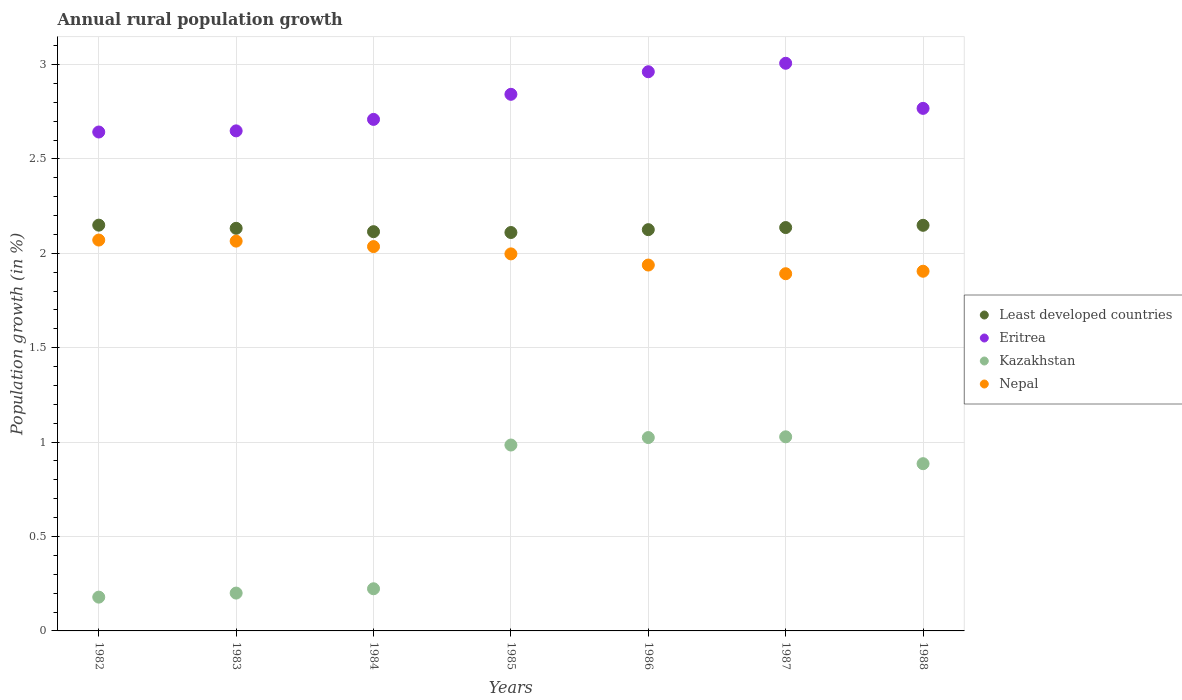How many different coloured dotlines are there?
Your answer should be compact. 4. What is the percentage of rural population growth in Kazakhstan in 1984?
Ensure brevity in your answer.  0.22. Across all years, what is the maximum percentage of rural population growth in Nepal?
Ensure brevity in your answer.  2.07. Across all years, what is the minimum percentage of rural population growth in Eritrea?
Your response must be concise. 2.64. What is the total percentage of rural population growth in Nepal in the graph?
Keep it short and to the point. 13.9. What is the difference between the percentage of rural population growth in Kazakhstan in 1984 and that in 1988?
Your answer should be very brief. -0.66. What is the difference between the percentage of rural population growth in Nepal in 1983 and the percentage of rural population growth in Kazakhstan in 1987?
Give a very brief answer. 1.04. What is the average percentage of rural population growth in Least developed countries per year?
Provide a short and direct response. 2.13. In the year 1983, what is the difference between the percentage of rural population growth in Kazakhstan and percentage of rural population growth in Least developed countries?
Your answer should be compact. -1.93. In how many years, is the percentage of rural population growth in Nepal greater than 0.6 %?
Your answer should be compact. 7. What is the ratio of the percentage of rural population growth in Least developed countries in 1982 to that in 1987?
Your answer should be compact. 1.01. What is the difference between the highest and the second highest percentage of rural population growth in Eritrea?
Keep it short and to the point. 0.04. What is the difference between the highest and the lowest percentage of rural population growth in Least developed countries?
Offer a very short reply. 0.04. Is it the case that in every year, the sum of the percentage of rural population growth in Least developed countries and percentage of rural population growth in Kazakhstan  is greater than the sum of percentage of rural population growth in Nepal and percentage of rural population growth in Eritrea?
Keep it short and to the point. No. Is it the case that in every year, the sum of the percentage of rural population growth in Nepal and percentage of rural population growth in Kazakhstan  is greater than the percentage of rural population growth in Eritrea?
Your answer should be compact. No. Is the percentage of rural population growth in Kazakhstan strictly less than the percentage of rural population growth in Least developed countries over the years?
Provide a succinct answer. Yes. How many dotlines are there?
Provide a short and direct response. 4. How many years are there in the graph?
Keep it short and to the point. 7. Are the values on the major ticks of Y-axis written in scientific E-notation?
Make the answer very short. No. Does the graph contain any zero values?
Your answer should be very brief. No. Does the graph contain grids?
Provide a succinct answer. Yes. What is the title of the graph?
Provide a succinct answer. Annual rural population growth. What is the label or title of the X-axis?
Your answer should be very brief. Years. What is the label or title of the Y-axis?
Make the answer very short. Population growth (in %). What is the Population growth (in %) in Least developed countries in 1982?
Your answer should be compact. 2.15. What is the Population growth (in %) of Eritrea in 1982?
Provide a short and direct response. 2.64. What is the Population growth (in %) of Kazakhstan in 1982?
Provide a succinct answer. 0.18. What is the Population growth (in %) in Nepal in 1982?
Offer a terse response. 2.07. What is the Population growth (in %) in Least developed countries in 1983?
Make the answer very short. 2.13. What is the Population growth (in %) of Eritrea in 1983?
Your answer should be very brief. 2.65. What is the Population growth (in %) in Kazakhstan in 1983?
Offer a terse response. 0.2. What is the Population growth (in %) in Nepal in 1983?
Provide a succinct answer. 2.06. What is the Population growth (in %) in Least developed countries in 1984?
Your answer should be very brief. 2.11. What is the Population growth (in %) in Eritrea in 1984?
Your answer should be very brief. 2.71. What is the Population growth (in %) of Kazakhstan in 1984?
Offer a very short reply. 0.22. What is the Population growth (in %) of Nepal in 1984?
Make the answer very short. 2.04. What is the Population growth (in %) in Least developed countries in 1985?
Your answer should be very brief. 2.11. What is the Population growth (in %) of Eritrea in 1985?
Give a very brief answer. 2.84. What is the Population growth (in %) in Kazakhstan in 1985?
Your answer should be very brief. 0.98. What is the Population growth (in %) in Nepal in 1985?
Your answer should be very brief. 2. What is the Population growth (in %) of Least developed countries in 1986?
Your response must be concise. 2.13. What is the Population growth (in %) in Eritrea in 1986?
Offer a terse response. 2.96. What is the Population growth (in %) of Kazakhstan in 1986?
Offer a very short reply. 1.02. What is the Population growth (in %) of Nepal in 1986?
Offer a terse response. 1.94. What is the Population growth (in %) of Least developed countries in 1987?
Your response must be concise. 2.14. What is the Population growth (in %) in Eritrea in 1987?
Offer a very short reply. 3.01. What is the Population growth (in %) in Kazakhstan in 1987?
Provide a short and direct response. 1.03. What is the Population growth (in %) in Nepal in 1987?
Make the answer very short. 1.89. What is the Population growth (in %) in Least developed countries in 1988?
Offer a very short reply. 2.15. What is the Population growth (in %) in Eritrea in 1988?
Give a very brief answer. 2.77. What is the Population growth (in %) of Kazakhstan in 1988?
Ensure brevity in your answer.  0.89. What is the Population growth (in %) in Nepal in 1988?
Ensure brevity in your answer.  1.91. Across all years, what is the maximum Population growth (in %) of Least developed countries?
Keep it short and to the point. 2.15. Across all years, what is the maximum Population growth (in %) of Eritrea?
Keep it short and to the point. 3.01. Across all years, what is the maximum Population growth (in %) in Kazakhstan?
Keep it short and to the point. 1.03. Across all years, what is the maximum Population growth (in %) in Nepal?
Offer a very short reply. 2.07. Across all years, what is the minimum Population growth (in %) of Least developed countries?
Your answer should be compact. 2.11. Across all years, what is the minimum Population growth (in %) in Eritrea?
Ensure brevity in your answer.  2.64. Across all years, what is the minimum Population growth (in %) of Kazakhstan?
Provide a short and direct response. 0.18. Across all years, what is the minimum Population growth (in %) in Nepal?
Your answer should be very brief. 1.89. What is the total Population growth (in %) of Least developed countries in the graph?
Keep it short and to the point. 14.92. What is the total Population growth (in %) in Eritrea in the graph?
Make the answer very short. 19.58. What is the total Population growth (in %) of Kazakhstan in the graph?
Offer a terse response. 4.53. What is the total Population growth (in %) in Nepal in the graph?
Keep it short and to the point. 13.9. What is the difference between the Population growth (in %) of Least developed countries in 1982 and that in 1983?
Make the answer very short. 0.02. What is the difference between the Population growth (in %) of Eritrea in 1982 and that in 1983?
Your response must be concise. -0.01. What is the difference between the Population growth (in %) of Kazakhstan in 1982 and that in 1983?
Offer a very short reply. -0.02. What is the difference between the Population growth (in %) of Nepal in 1982 and that in 1983?
Make the answer very short. 0.01. What is the difference between the Population growth (in %) in Least developed countries in 1982 and that in 1984?
Ensure brevity in your answer.  0.03. What is the difference between the Population growth (in %) in Eritrea in 1982 and that in 1984?
Offer a very short reply. -0.07. What is the difference between the Population growth (in %) of Kazakhstan in 1982 and that in 1984?
Provide a succinct answer. -0.04. What is the difference between the Population growth (in %) of Nepal in 1982 and that in 1984?
Keep it short and to the point. 0.03. What is the difference between the Population growth (in %) in Least developed countries in 1982 and that in 1985?
Make the answer very short. 0.04. What is the difference between the Population growth (in %) of Eritrea in 1982 and that in 1985?
Your response must be concise. -0.2. What is the difference between the Population growth (in %) in Kazakhstan in 1982 and that in 1985?
Keep it short and to the point. -0.81. What is the difference between the Population growth (in %) of Nepal in 1982 and that in 1985?
Your answer should be compact. 0.07. What is the difference between the Population growth (in %) in Least developed countries in 1982 and that in 1986?
Your answer should be very brief. 0.02. What is the difference between the Population growth (in %) of Eritrea in 1982 and that in 1986?
Keep it short and to the point. -0.32. What is the difference between the Population growth (in %) of Kazakhstan in 1982 and that in 1986?
Offer a terse response. -0.85. What is the difference between the Population growth (in %) of Nepal in 1982 and that in 1986?
Offer a very short reply. 0.13. What is the difference between the Population growth (in %) in Least developed countries in 1982 and that in 1987?
Make the answer very short. 0.01. What is the difference between the Population growth (in %) of Eritrea in 1982 and that in 1987?
Offer a very short reply. -0.36. What is the difference between the Population growth (in %) of Kazakhstan in 1982 and that in 1987?
Offer a very short reply. -0.85. What is the difference between the Population growth (in %) of Nepal in 1982 and that in 1987?
Offer a terse response. 0.18. What is the difference between the Population growth (in %) in Least developed countries in 1982 and that in 1988?
Keep it short and to the point. 0. What is the difference between the Population growth (in %) of Eritrea in 1982 and that in 1988?
Provide a short and direct response. -0.13. What is the difference between the Population growth (in %) in Kazakhstan in 1982 and that in 1988?
Offer a terse response. -0.71. What is the difference between the Population growth (in %) in Nepal in 1982 and that in 1988?
Provide a succinct answer. 0.17. What is the difference between the Population growth (in %) in Least developed countries in 1983 and that in 1984?
Offer a very short reply. 0.02. What is the difference between the Population growth (in %) in Eritrea in 1983 and that in 1984?
Your answer should be compact. -0.06. What is the difference between the Population growth (in %) of Kazakhstan in 1983 and that in 1984?
Make the answer very short. -0.02. What is the difference between the Population growth (in %) in Nepal in 1983 and that in 1984?
Give a very brief answer. 0.03. What is the difference between the Population growth (in %) in Least developed countries in 1983 and that in 1985?
Your answer should be very brief. 0.02. What is the difference between the Population growth (in %) in Eritrea in 1983 and that in 1985?
Ensure brevity in your answer.  -0.19. What is the difference between the Population growth (in %) of Kazakhstan in 1983 and that in 1985?
Provide a short and direct response. -0.78. What is the difference between the Population growth (in %) in Nepal in 1983 and that in 1985?
Provide a short and direct response. 0.07. What is the difference between the Population growth (in %) of Least developed countries in 1983 and that in 1986?
Make the answer very short. 0.01. What is the difference between the Population growth (in %) of Eritrea in 1983 and that in 1986?
Your answer should be compact. -0.31. What is the difference between the Population growth (in %) in Kazakhstan in 1983 and that in 1986?
Your response must be concise. -0.82. What is the difference between the Population growth (in %) of Nepal in 1983 and that in 1986?
Keep it short and to the point. 0.13. What is the difference between the Population growth (in %) of Least developed countries in 1983 and that in 1987?
Offer a very short reply. -0. What is the difference between the Population growth (in %) of Eritrea in 1983 and that in 1987?
Give a very brief answer. -0.36. What is the difference between the Population growth (in %) of Kazakhstan in 1983 and that in 1987?
Your response must be concise. -0.83. What is the difference between the Population growth (in %) in Nepal in 1983 and that in 1987?
Offer a terse response. 0.17. What is the difference between the Population growth (in %) in Least developed countries in 1983 and that in 1988?
Make the answer very short. -0.02. What is the difference between the Population growth (in %) of Eritrea in 1983 and that in 1988?
Provide a succinct answer. -0.12. What is the difference between the Population growth (in %) of Kazakhstan in 1983 and that in 1988?
Offer a very short reply. -0.69. What is the difference between the Population growth (in %) of Nepal in 1983 and that in 1988?
Provide a short and direct response. 0.16. What is the difference between the Population growth (in %) in Least developed countries in 1984 and that in 1985?
Your answer should be compact. 0. What is the difference between the Population growth (in %) in Eritrea in 1984 and that in 1985?
Keep it short and to the point. -0.13. What is the difference between the Population growth (in %) of Kazakhstan in 1984 and that in 1985?
Keep it short and to the point. -0.76. What is the difference between the Population growth (in %) of Nepal in 1984 and that in 1985?
Provide a short and direct response. 0.04. What is the difference between the Population growth (in %) of Least developed countries in 1984 and that in 1986?
Your answer should be very brief. -0.01. What is the difference between the Population growth (in %) in Eritrea in 1984 and that in 1986?
Provide a short and direct response. -0.25. What is the difference between the Population growth (in %) of Kazakhstan in 1984 and that in 1986?
Provide a succinct answer. -0.8. What is the difference between the Population growth (in %) in Nepal in 1984 and that in 1986?
Offer a very short reply. 0.1. What is the difference between the Population growth (in %) of Least developed countries in 1984 and that in 1987?
Your answer should be compact. -0.02. What is the difference between the Population growth (in %) of Eritrea in 1984 and that in 1987?
Keep it short and to the point. -0.3. What is the difference between the Population growth (in %) in Kazakhstan in 1984 and that in 1987?
Your answer should be very brief. -0.8. What is the difference between the Population growth (in %) in Nepal in 1984 and that in 1987?
Make the answer very short. 0.14. What is the difference between the Population growth (in %) of Least developed countries in 1984 and that in 1988?
Ensure brevity in your answer.  -0.03. What is the difference between the Population growth (in %) in Eritrea in 1984 and that in 1988?
Offer a terse response. -0.06. What is the difference between the Population growth (in %) of Kazakhstan in 1984 and that in 1988?
Offer a very short reply. -0.66. What is the difference between the Population growth (in %) of Nepal in 1984 and that in 1988?
Provide a short and direct response. 0.13. What is the difference between the Population growth (in %) in Least developed countries in 1985 and that in 1986?
Your answer should be very brief. -0.02. What is the difference between the Population growth (in %) of Eritrea in 1985 and that in 1986?
Provide a succinct answer. -0.12. What is the difference between the Population growth (in %) in Kazakhstan in 1985 and that in 1986?
Ensure brevity in your answer.  -0.04. What is the difference between the Population growth (in %) of Nepal in 1985 and that in 1986?
Provide a succinct answer. 0.06. What is the difference between the Population growth (in %) in Least developed countries in 1985 and that in 1987?
Your answer should be compact. -0.03. What is the difference between the Population growth (in %) of Eritrea in 1985 and that in 1987?
Give a very brief answer. -0.16. What is the difference between the Population growth (in %) of Kazakhstan in 1985 and that in 1987?
Your response must be concise. -0.04. What is the difference between the Population growth (in %) in Nepal in 1985 and that in 1987?
Your response must be concise. 0.11. What is the difference between the Population growth (in %) in Least developed countries in 1985 and that in 1988?
Give a very brief answer. -0.04. What is the difference between the Population growth (in %) in Eritrea in 1985 and that in 1988?
Your answer should be very brief. 0.07. What is the difference between the Population growth (in %) of Kazakhstan in 1985 and that in 1988?
Ensure brevity in your answer.  0.1. What is the difference between the Population growth (in %) of Nepal in 1985 and that in 1988?
Offer a terse response. 0.09. What is the difference between the Population growth (in %) of Least developed countries in 1986 and that in 1987?
Give a very brief answer. -0.01. What is the difference between the Population growth (in %) of Eritrea in 1986 and that in 1987?
Your response must be concise. -0.04. What is the difference between the Population growth (in %) of Kazakhstan in 1986 and that in 1987?
Your response must be concise. -0. What is the difference between the Population growth (in %) of Nepal in 1986 and that in 1987?
Provide a short and direct response. 0.05. What is the difference between the Population growth (in %) in Least developed countries in 1986 and that in 1988?
Your response must be concise. -0.02. What is the difference between the Population growth (in %) in Eritrea in 1986 and that in 1988?
Keep it short and to the point. 0.19. What is the difference between the Population growth (in %) of Kazakhstan in 1986 and that in 1988?
Provide a succinct answer. 0.14. What is the difference between the Population growth (in %) in Nepal in 1986 and that in 1988?
Your response must be concise. 0.03. What is the difference between the Population growth (in %) of Least developed countries in 1987 and that in 1988?
Ensure brevity in your answer.  -0.01. What is the difference between the Population growth (in %) of Eritrea in 1987 and that in 1988?
Keep it short and to the point. 0.24. What is the difference between the Population growth (in %) in Kazakhstan in 1987 and that in 1988?
Provide a short and direct response. 0.14. What is the difference between the Population growth (in %) of Nepal in 1987 and that in 1988?
Your response must be concise. -0.01. What is the difference between the Population growth (in %) in Least developed countries in 1982 and the Population growth (in %) in Eritrea in 1983?
Ensure brevity in your answer.  -0.5. What is the difference between the Population growth (in %) in Least developed countries in 1982 and the Population growth (in %) in Kazakhstan in 1983?
Make the answer very short. 1.95. What is the difference between the Population growth (in %) in Least developed countries in 1982 and the Population growth (in %) in Nepal in 1983?
Provide a short and direct response. 0.08. What is the difference between the Population growth (in %) in Eritrea in 1982 and the Population growth (in %) in Kazakhstan in 1983?
Offer a very short reply. 2.44. What is the difference between the Population growth (in %) of Eritrea in 1982 and the Population growth (in %) of Nepal in 1983?
Your answer should be compact. 0.58. What is the difference between the Population growth (in %) of Kazakhstan in 1982 and the Population growth (in %) of Nepal in 1983?
Provide a succinct answer. -1.89. What is the difference between the Population growth (in %) of Least developed countries in 1982 and the Population growth (in %) of Eritrea in 1984?
Your answer should be very brief. -0.56. What is the difference between the Population growth (in %) of Least developed countries in 1982 and the Population growth (in %) of Kazakhstan in 1984?
Offer a terse response. 1.93. What is the difference between the Population growth (in %) in Least developed countries in 1982 and the Population growth (in %) in Nepal in 1984?
Your answer should be very brief. 0.11. What is the difference between the Population growth (in %) of Eritrea in 1982 and the Population growth (in %) of Kazakhstan in 1984?
Your response must be concise. 2.42. What is the difference between the Population growth (in %) in Eritrea in 1982 and the Population growth (in %) in Nepal in 1984?
Make the answer very short. 0.61. What is the difference between the Population growth (in %) of Kazakhstan in 1982 and the Population growth (in %) of Nepal in 1984?
Give a very brief answer. -1.86. What is the difference between the Population growth (in %) in Least developed countries in 1982 and the Population growth (in %) in Eritrea in 1985?
Your answer should be compact. -0.69. What is the difference between the Population growth (in %) of Least developed countries in 1982 and the Population growth (in %) of Kazakhstan in 1985?
Your answer should be very brief. 1.16. What is the difference between the Population growth (in %) in Least developed countries in 1982 and the Population growth (in %) in Nepal in 1985?
Keep it short and to the point. 0.15. What is the difference between the Population growth (in %) in Eritrea in 1982 and the Population growth (in %) in Kazakhstan in 1985?
Offer a very short reply. 1.66. What is the difference between the Population growth (in %) of Eritrea in 1982 and the Population growth (in %) of Nepal in 1985?
Your answer should be very brief. 0.65. What is the difference between the Population growth (in %) of Kazakhstan in 1982 and the Population growth (in %) of Nepal in 1985?
Ensure brevity in your answer.  -1.82. What is the difference between the Population growth (in %) of Least developed countries in 1982 and the Population growth (in %) of Eritrea in 1986?
Keep it short and to the point. -0.81. What is the difference between the Population growth (in %) in Least developed countries in 1982 and the Population growth (in %) in Nepal in 1986?
Your answer should be compact. 0.21. What is the difference between the Population growth (in %) in Eritrea in 1982 and the Population growth (in %) in Kazakhstan in 1986?
Your answer should be very brief. 1.62. What is the difference between the Population growth (in %) of Eritrea in 1982 and the Population growth (in %) of Nepal in 1986?
Your answer should be compact. 0.7. What is the difference between the Population growth (in %) of Kazakhstan in 1982 and the Population growth (in %) of Nepal in 1986?
Your response must be concise. -1.76. What is the difference between the Population growth (in %) of Least developed countries in 1982 and the Population growth (in %) of Eritrea in 1987?
Offer a terse response. -0.86. What is the difference between the Population growth (in %) in Least developed countries in 1982 and the Population growth (in %) in Kazakhstan in 1987?
Your answer should be compact. 1.12. What is the difference between the Population growth (in %) of Least developed countries in 1982 and the Population growth (in %) of Nepal in 1987?
Your answer should be very brief. 0.26. What is the difference between the Population growth (in %) in Eritrea in 1982 and the Population growth (in %) in Kazakhstan in 1987?
Your answer should be compact. 1.61. What is the difference between the Population growth (in %) in Eritrea in 1982 and the Population growth (in %) in Nepal in 1987?
Make the answer very short. 0.75. What is the difference between the Population growth (in %) in Kazakhstan in 1982 and the Population growth (in %) in Nepal in 1987?
Offer a very short reply. -1.71. What is the difference between the Population growth (in %) of Least developed countries in 1982 and the Population growth (in %) of Eritrea in 1988?
Provide a short and direct response. -0.62. What is the difference between the Population growth (in %) of Least developed countries in 1982 and the Population growth (in %) of Kazakhstan in 1988?
Your answer should be very brief. 1.26. What is the difference between the Population growth (in %) in Least developed countries in 1982 and the Population growth (in %) in Nepal in 1988?
Offer a very short reply. 0.24. What is the difference between the Population growth (in %) of Eritrea in 1982 and the Population growth (in %) of Kazakhstan in 1988?
Offer a very short reply. 1.76. What is the difference between the Population growth (in %) in Eritrea in 1982 and the Population growth (in %) in Nepal in 1988?
Provide a short and direct response. 0.74. What is the difference between the Population growth (in %) in Kazakhstan in 1982 and the Population growth (in %) in Nepal in 1988?
Give a very brief answer. -1.73. What is the difference between the Population growth (in %) in Least developed countries in 1983 and the Population growth (in %) in Eritrea in 1984?
Ensure brevity in your answer.  -0.58. What is the difference between the Population growth (in %) in Least developed countries in 1983 and the Population growth (in %) in Kazakhstan in 1984?
Your answer should be compact. 1.91. What is the difference between the Population growth (in %) of Least developed countries in 1983 and the Population growth (in %) of Nepal in 1984?
Your answer should be compact. 0.1. What is the difference between the Population growth (in %) in Eritrea in 1983 and the Population growth (in %) in Kazakhstan in 1984?
Provide a short and direct response. 2.43. What is the difference between the Population growth (in %) of Eritrea in 1983 and the Population growth (in %) of Nepal in 1984?
Offer a very short reply. 0.61. What is the difference between the Population growth (in %) of Kazakhstan in 1983 and the Population growth (in %) of Nepal in 1984?
Your answer should be very brief. -1.84. What is the difference between the Population growth (in %) of Least developed countries in 1983 and the Population growth (in %) of Eritrea in 1985?
Your answer should be compact. -0.71. What is the difference between the Population growth (in %) in Least developed countries in 1983 and the Population growth (in %) in Kazakhstan in 1985?
Give a very brief answer. 1.15. What is the difference between the Population growth (in %) of Least developed countries in 1983 and the Population growth (in %) of Nepal in 1985?
Provide a succinct answer. 0.14. What is the difference between the Population growth (in %) in Eritrea in 1983 and the Population growth (in %) in Kazakhstan in 1985?
Make the answer very short. 1.66. What is the difference between the Population growth (in %) in Eritrea in 1983 and the Population growth (in %) in Nepal in 1985?
Make the answer very short. 0.65. What is the difference between the Population growth (in %) of Kazakhstan in 1983 and the Population growth (in %) of Nepal in 1985?
Offer a very short reply. -1.8. What is the difference between the Population growth (in %) in Least developed countries in 1983 and the Population growth (in %) in Eritrea in 1986?
Make the answer very short. -0.83. What is the difference between the Population growth (in %) of Least developed countries in 1983 and the Population growth (in %) of Kazakhstan in 1986?
Provide a short and direct response. 1.11. What is the difference between the Population growth (in %) of Least developed countries in 1983 and the Population growth (in %) of Nepal in 1986?
Offer a terse response. 0.19. What is the difference between the Population growth (in %) of Eritrea in 1983 and the Population growth (in %) of Kazakhstan in 1986?
Offer a terse response. 1.62. What is the difference between the Population growth (in %) of Eritrea in 1983 and the Population growth (in %) of Nepal in 1986?
Give a very brief answer. 0.71. What is the difference between the Population growth (in %) in Kazakhstan in 1983 and the Population growth (in %) in Nepal in 1986?
Your answer should be compact. -1.74. What is the difference between the Population growth (in %) of Least developed countries in 1983 and the Population growth (in %) of Eritrea in 1987?
Provide a short and direct response. -0.87. What is the difference between the Population growth (in %) in Least developed countries in 1983 and the Population growth (in %) in Kazakhstan in 1987?
Your response must be concise. 1.1. What is the difference between the Population growth (in %) of Least developed countries in 1983 and the Population growth (in %) of Nepal in 1987?
Your answer should be very brief. 0.24. What is the difference between the Population growth (in %) of Eritrea in 1983 and the Population growth (in %) of Kazakhstan in 1987?
Provide a succinct answer. 1.62. What is the difference between the Population growth (in %) of Eritrea in 1983 and the Population growth (in %) of Nepal in 1987?
Keep it short and to the point. 0.76. What is the difference between the Population growth (in %) of Kazakhstan in 1983 and the Population growth (in %) of Nepal in 1987?
Your answer should be very brief. -1.69. What is the difference between the Population growth (in %) of Least developed countries in 1983 and the Population growth (in %) of Eritrea in 1988?
Your response must be concise. -0.64. What is the difference between the Population growth (in %) of Least developed countries in 1983 and the Population growth (in %) of Kazakhstan in 1988?
Offer a very short reply. 1.25. What is the difference between the Population growth (in %) of Least developed countries in 1983 and the Population growth (in %) of Nepal in 1988?
Keep it short and to the point. 0.23. What is the difference between the Population growth (in %) in Eritrea in 1983 and the Population growth (in %) in Kazakhstan in 1988?
Your answer should be very brief. 1.76. What is the difference between the Population growth (in %) in Eritrea in 1983 and the Population growth (in %) in Nepal in 1988?
Your response must be concise. 0.74. What is the difference between the Population growth (in %) in Kazakhstan in 1983 and the Population growth (in %) in Nepal in 1988?
Provide a short and direct response. -1.7. What is the difference between the Population growth (in %) of Least developed countries in 1984 and the Population growth (in %) of Eritrea in 1985?
Provide a succinct answer. -0.73. What is the difference between the Population growth (in %) in Least developed countries in 1984 and the Population growth (in %) in Kazakhstan in 1985?
Your answer should be compact. 1.13. What is the difference between the Population growth (in %) in Least developed countries in 1984 and the Population growth (in %) in Nepal in 1985?
Ensure brevity in your answer.  0.12. What is the difference between the Population growth (in %) in Eritrea in 1984 and the Population growth (in %) in Kazakhstan in 1985?
Make the answer very short. 1.72. What is the difference between the Population growth (in %) in Eritrea in 1984 and the Population growth (in %) in Nepal in 1985?
Keep it short and to the point. 0.71. What is the difference between the Population growth (in %) of Kazakhstan in 1984 and the Population growth (in %) of Nepal in 1985?
Your response must be concise. -1.77. What is the difference between the Population growth (in %) of Least developed countries in 1984 and the Population growth (in %) of Eritrea in 1986?
Make the answer very short. -0.85. What is the difference between the Population growth (in %) of Least developed countries in 1984 and the Population growth (in %) of Kazakhstan in 1986?
Provide a short and direct response. 1.09. What is the difference between the Population growth (in %) of Least developed countries in 1984 and the Population growth (in %) of Nepal in 1986?
Provide a succinct answer. 0.18. What is the difference between the Population growth (in %) in Eritrea in 1984 and the Population growth (in %) in Kazakhstan in 1986?
Keep it short and to the point. 1.69. What is the difference between the Population growth (in %) of Eritrea in 1984 and the Population growth (in %) of Nepal in 1986?
Your response must be concise. 0.77. What is the difference between the Population growth (in %) of Kazakhstan in 1984 and the Population growth (in %) of Nepal in 1986?
Offer a terse response. -1.71. What is the difference between the Population growth (in %) of Least developed countries in 1984 and the Population growth (in %) of Eritrea in 1987?
Provide a short and direct response. -0.89. What is the difference between the Population growth (in %) of Least developed countries in 1984 and the Population growth (in %) of Kazakhstan in 1987?
Your answer should be compact. 1.09. What is the difference between the Population growth (in %) of Least developed countries in 1984 and the Population growth (in %) of Nepal in 1987?
Offer a terse response. 0.22. What is the difference between the Population growth (in %) in Eritrea in 1984 and the Population growth (in %) in Kazakhstan in 1987?
Make the answer very short. 1.68. What is the difference between the Population growth (in %) in Eritrea in 1984 and the Population growth (in %) in Nepal in 1987?
Your answer should be compact. 0.82. What is the difference between the Population growth (in %) in Kazakhstan in 1984 and the Population growth (in %) in Nepal in 1987?
Your answer should be very brief. -1.67. What is the difference between the Population growth (in %) in Least developed countries in 1984 and the Population growth (in %) in Eritrea in 1988?
Provide a succinct answer. -0.65. What is the difference between the Population growth (in %) in Least developed countries in 1984 and the Population growth (in %) in Kazakhstan in 1988?
Ensure brevity in your answer.  1.23. What is the difference between the Population growth (in %) in Least developed countries in 1984 and the Population growth (in %) in Nepal in 1988?
Provide a succinct answer. 0.21. What is the difference between the Population growth (in %) of Eritrea in 1984 and the Population growth (in %) of Kazakhstan in 1988?
Your answer should be compact. 1.82. What is the difference between the Population growth (in %) in Eritrea in 1984 and the Population growth (in %) in Nepal in 1988?
Offer a very short reply. 0.8. What is the difference between the Population growth (in %) of Kazakhstan in 1984 and the Population growth (in %) of Nepal in 1988?
Offer a terse response. -1.68. What is the difference between the Population growth (in %) in Least developed countries in 1985 and the Population growth (in %) in Eritrea in 1986?
Offer a very short reply. -0.85. What is the difference between the Population growth (in %) in Least developed countries in 1985 and the Population growth (in %) in Kazakhstan in 1986?
Give a very brief answer. 1.09. What is the difference between the Population growth (in %) of Least developed countries in 1985 and the Population growth (in %) of Nepal in 1986?
Offer a very short reply. 0.17. What is the difference between the Population growth (in %) of Eritrea in 1985 and the Population growth (in %) of Kazakhstan in 1986?
Your answer should be very brief. 1.82. What is the difference between the Population growth (in %) of Eritrea in 1985 and the Population growth (in %) of Nepal in 1986?
Your response must be concise. 0.9. What is the difference between the Population growth (in %) of Kazakhstan in 1985 and the Population growth (in %) of Nepal in 1986?
Ensure brevity in your answer.  -0.95. What is the difference between the Population growth (in %) in Least developed countries in 1985 and the Population growth (in %) in Eritrea in 1987?
Offer a very short reply. -0.9. What is the difference between the Population growth (in %) of Least developed countries in 1985 and the Population growth (in %) of Kazakhstan in 1987?
Offer a very short reply. 1.08. What is the difference between the Population growth (in %) in Least developed countries in 1985 and the Population growth (in %) in Nepal in 1987?
Ensure brevity in your answer.  0.22. What is the difference between the Population growth (in %) of Eritrea in 1985 and the Population growth (in %) of Kazakhstan in 1987?
Ensure brevity in your answer.  1.81. What is the difference between the Population growth (in %) in Eritrea in 1985 and the Population growth (in %) in Nepal in 1987?
Your response must be concise. 0.95. What is the difference between the Population growth (in %) in Kazakhstan in 1985 and the Population growth (in %) in Nepal in 1987?
Provide a succinct answer. -0.91. What is the difference between the Population growth (in %) of Least developed countries in 1985 and the Population growth (in %) of Eritrea in 1988?
Provide a succinct answer. -0.66. What is the difference between the Population growth (in %) in Least developed countries in 1985 and the Population growth (in %) in Kazakhstan in 1988?
Offer a terse response. 1.22. What is the difference between the Population growth (in %) of Least developed countries in 1985 and the Population growth (in %) of Nepal in 1988?
Keep it short and to the point. 0.21. What is the difference between the Population growth (in %) in Eritrea in 1985 and the Population growth (in %) in Kazakhstan in 1988?
Your answer should be very brief. 1.96. What is the difference between the Population growth (in %) of Eritrea in 1985 and the Population growth (in %) of Nepal in 1988?
Your response must be concise. 0.94. What is the difference between the Population growth (in %) of Kazakhstan in 1985 and the Population growth (in %) of Nepal in 1988?
Offer a terse response. -0.92. What is the difference between the Population growth (in %) in Least developed countries in 1986 and the Population growth (in %) in Eritrea in 1987?
Keep it short and to the point. -0.88. What is the difference between the Population growth (in %) of Least developed countries in 1986 and the Population growth (in %) of Kazakhstan in 1987?
Give a very brief answer. 1.1. What is the difference between the Population growth (in %) of Least developed countries in 1986 and the Population growth (in %) of Nepal in 1987?
Provide a short and direct response. 0.23. What is the difference between the Population growth (in %) of Eritrea in 1986 and the Population growth (in %) of Kazakhstan in 1987?
Your answer should be very brief. 1.93. What is the difference between the Population growth (in %) in Eritrea in 1986 and the Population growth (in %) in Nepal in 1987?
Offer a very short reply. 1.07. What is the difference between the Population growth (in %) in Kazakhstan in 1986 and the Population growth (in %) in Nepal in 1987?
Your answer should be very brief. -0.87. What is the difference between the Population growth (in %) in Least developed countries in 1986 and the Population growth (in %) in Eritrea in 1988?
Make the answer very short. -0.64. What is the difference between the Population growth (in %) of Least developed countries in 1986 and the Population growth (in %) of Kazakhstan in 1988?
Provide a succinct answer. 1.24. What is the difference between the Population growth (in %) in Least developed countries in 1986 and the Population growth (in %) in Nepal in 1988?
Offer a terse response. 0.22. What is the difference between the Population growth (in %) of Eritrea in 1986 and the Population growth (in %) of Kazakhstan in 1988?
Ensure brevity in your answer.  2.08. What is the difference between the Population growth (in %) in Eritrea in 1986 and the Population growth (in %) in Nepal in 1988?
Provide a succinct answer. 1.06. What is the difference between the Population growth (in %) in Kazakhstan in 1986 and the Population growth (in %) in Nepal in 1988?
Your response must be concise. -0.88. What is the difference between the Population growth (in %) in Least developed countries in 1987 and the Population growth (in %) in Eritrea in 1988?
Your answer should be compact. -0.63. What is the difference between the Population growth (in %) in Least developed countries in 1987 and the Population growth (in %) in Kazakhstan in 1988?
Provide a short and direct response. 1.25. What is the difference between the Population growth (in %) of Least developed countries in 1987 and the Population growth (in %) of Nepal in 1988?
Provide a succinct answer. 0.23. What is the difference between the Population growth (in %) in Eritrea in 1987 and the Population growth (in %) in Kazakhstan in 1988?
Offer a terse response. 2.12. What is the difference between the Population growth (in %) in Eritrea in 1987 and the Population growth (in %) in Nepal in 1988?
Your answer should be compact. 1.1. What is the difference between the Population growth (in %) in Kazakhstan in 1987 and the Population growth (in %) in Nepal in 1988?
Give a very brief answer. -0.88. What is the average Population growth (in %) in Least developed countries per year?
Offer a very short reply. 2.13. What is the average Population growth (in %) of Eritrea per year?
Keep it short and to the point. 2.8. What is the average Population growth (in %) in Kazakhstan per year?
Offer a terse response. 0.65. What is the average Population growth (in %) in Nepal per year?
Your answer should be very brief. 1.99. In the year 1982, what is the difference between the Population growth (in %) in Least developed countries and Population growth (in %) in Eritrea?
Ensure brevity in your answer.  -0.49. In the year 1982, what is the difference between the Population growth (in %) of Least developed countries and Population growth (in %) of Kazakhstan?
Your answer should be compact. 1.97. In the year 1982, what is the difference between the Population growth (in %) in Least developed countries and Population growth (in %) in Nepal?
Keep it short and to the point. 0.08. In the year 1982, what is the difference between the Population growth (in %) of Eritrea and Population growth (in %) of Kazakhstan?
Ensure brevity in your answer.  2.46. In the year 1982, what is the difference between the Population growth (in %) in Eritrea and Population growth (in %) in Nepal?
Keep it short and to the point. 0.57. In the year 1982, what is the difference between the Population growth (in %) in Kazakhstan and Population growth (in %) in Nepal?
Your response must be concise. -1.89. In the year 1983, what is the difference between the Population growth (in %) in Least developed countries and Population growth (in %) in Eritrea?
Provide a short and direct response. -0.52. In the year 1983, what is the difference between the Population growth (in %) of Least developed countries and Population growth (in %) of Kazakhstan?
Offer a very short reply. 1.93. In the year 1983, what is the difference between the Population growth (in %) of Least developed countries and Population growth (in %) of Nepal?
Your answer should be very brief. 0.07. In the year 1983, what is the difference between the Population growth (in %) in Eritrea and Population growth (in %) in Kazakhstan?
Provide a succinct answer. 2.45. In the year 1983, what is the difference between the Population growth (in %) of Eritrea and Population growth (in %) of Nepal?
Your answer should be very brief. 0.58. In the year 1983, what is the difference between the Population growth (in %) in Kazakhstan and Population growth (in %) in Nepal?
Make the answer very short. -1.86. In the year 1984, what is the difference between the Population growth (in %) of Least developed countries and Population growth (in %) of Eritrea?
Ensure brevity in your answer.  -0.59. In the year 1984, what is the difference between the Population growth (in %) of Least developed countries and Population growth (in %) of Kazakhstan?
Your response must be concise. 1.89. In the year 1984, what is the difference between the Population growth (in %) in Least developed countries and Population growth (in %) in Nepal?
Make the answer very short. 0.08. In the year 1984, what is the difference between the Population growth (in %) in Eritrea and Population growth (in %) in Kazakhstan?
Your answer should be compact. 2.49. In the year 1984, what is the difference between the Population growth (in %) in Eritrea and Population growth (in %) in Nepal?
Make the answer very short. 0.67. In the year 1984, what is the difference between the Population growth (in %) in Kazakhstan and Population growth (in %) in Nepal?
Keep it short and to the point. -1.81. In the year 1985, what is the difference between the Population growth (in %) of Least developed countries and Population growth (in %) of Eritrea?
Provide a short and direct response. -0.73. In the year 1985, what is the difference between the Population growth (in %) in Least developed countries and Population growth (in %) in Kazakhstan?
Your answer should be compact. 1.13. In the year 1985, what is the difference between the Population growth (in %) in Least developed countries and Population growth (in %) in Nepal?
Make the answer very short. 0.11. In the year 1985, what is the difference between the Population growth (in %) of Eritrea and Population growth (in %) of Kazakhstan?
Provide a short and direct response. 1.86. In the year 1985, what is the difference between the Population growth (in %) of Eritrea and Population growth (in %) of Nepal?
Offer a terse response. 0.85. In the year 1985, what is the difference between the Population growth (in %) of Kazakhstan and Population growth (in %) of Nepal?
Keep it short and to the point. -1.01. In the year 1986, what is the difference between the Population growth (in %) of Least developed countries and Population growth (in %) of Eritrea?
Offer a very short reply. -0.84. In the year 1986, what is the difference between the Population growth (in %) in Least developed countries and Population growth (in %) in Kazakhstan?
Give a very brief answer. 1.1. In the year 1986, what is the difference between the Population growth (in %) in Least developed countries and Population growth (in %) in Nepal?
Offer a very short reply. 0.19. In the year 1986, what is the difference between the Population growth (in %) in Eritrea and Population growth (in %) in Kazakhstan?
Provide a short and direct response. 1.94. In the year 1986, what is the difference between the Population growth (in %) in Eritrea and Population growth (in %) in Nepal?
Your answer should be compact. 1.02. In the year 1986, what is the difference between the Population growth (in %) of Kazakhstan and Population growth (in %) of Nepal?
Provide a succinct answer. -0.91. In the year 1987, what is the difference between the Population growth (in %) in Least developed countries and Population growth (in %) in Eritrea?
Your answer should be compact. -0.87. In the year 1987, what is the difference between the Population growth (in %) in Least developed countries and Population growth (in %) in Kazakhstan?
Provide a short and direct response. 1.11. In the year 1987, what is the difference between the Population growth (in %) in Least developed countries and Population growth (in %) in Nepal?
Provide a succinct answer. 0.24. In the year 1987, what is the difference between the Population growth (in %) in Eritrea and Population growth (in %) in Kazakhstan?
Offer a terse response. 1.98. In the year 1987, what is the difference between the Population growth (in %) of Eritrea and Population growth (in %) of Nepal?
Offer a very short reply. 1.11. In the year 1987, what is the difference between the Population growth (in %) in Kazakhstan and Population growth (in %) in Nepal?
Your response must be concise. -0.86. In the year 1988, what is the difference between the Population growth (in %) in Least developed countries and Population growth (in %) in Eritrea?
Provide a short and direct response. -0.62. In the year 1988, what is the difference between the Population growth (in %) in Least developed countries and Population growth (in %) in Kazakhstan?
Your response must be concise. 1.26. In the year 1988, what is the difference between the Population growth (in %) in Least developed countries and Population growth (in %) in Nepal?
Your response must be concise. 0.24. In the year 1988, what is the difference between the Population growth (in %) in Eritrea and Population growth (in %) in Kazakhstan?
Ensure brevity in your answer.  1.88. In the year 1988, what is the difference between the Population growth (in %) of Eritrea and Population growth (in %) of Nepal?
Offer a very short reply. 0.86. In the year 1988, what is the difference between the Population growth (in %) in Kazakhstan and Population growth (in %) in Nepal?
Keep it short and to the point. -1.02. What is the ratio of the Population growth (in %) of Least developed countries in 1982 to that in 1983?
Your answer should be very brief. 1.01. What is the ratio of the Population growth (in %) of Eritrea in 1982 to that in 1983?
Provide a short and direct response. 1. What is the ratio of the Population growth (in %) in Kazakhstan in 1982 to that in 1983?
Your answer should be compact. 0.89. What is the ratio of the Population growth (in %) of Least developed countries in 1982 to that in 1984?
Offer a very short reply. 1.02. What is the ratio of the Population growth (in %) in Eritrea in 1982 to that in 1984?
Provide a short and direct response. 0.98. What is the ratio of the Population growth (in %) of Kazakhstan in 1982 to that in 1984?
Your answer should be compact. 0.8. What is the ratio of the Population growth (in %) of Nepal in 1982 to that in 1984?
Your response must be concise. 1.02. What is the ratio of the Population growth (in %) in Least developed countries in 1982 to that in 1985?
Your answer should be compact. 1.02. What is the ratio of the Population growth (in %) of Eritrea in 1982 to that in 1985?
Your answer should be very brief. 0.93. What is the ratio of the Population growth (in %) of Kazakhstan in 1982 to that in 1985?
Provide a short and direct response. 0.18. What is the ratio of the Population growth (in %) in Nepal in 1982 to that in 1985?
Offer a terse response. 1.04. What is the ratio of the Population growth (in %) of Least developed countries in 1982 to that in 1986?
Make the answer very short. 1.01. What is the ratio of the Population growth (in %) of Eritrea in 1982 to that in 1986?
Your answer should be compact. 0.89. What is the ratio of the Population growth (in %) of Kazakhstan in 1982 to that in 1986?
Provide a short and direct response. 0.17. What is the ratio of the Population growth (in %) of Nepal in 1982 to that in 1986?
Offer a very short reply. 1.07. What is the ratio of the Population growth (in %) in Least developed countries in 1982 to that in 1987?
Give a very brief answer. 1.01. What is the ratio of the Population growth (in %) of Eritrea in 1982 to that in 1987?
Offer a terse response. 0.88. What is the ratio of the Population growth (in %) in Kazakhstan in 1982 to that in 1987?
Your answer should be compact. 0.17. What is the ratio of the Population growth (in %) of Nepal in 1982 to that in 1987?
Offer a terse response. 1.09. What is the ratio of the Population growth (in %) of Least developed countries in 1982 to that in 1988?
Your answer should be compact. 1. What is the ratio of the Population growth (in %) in Eritrea in 1982 to that in 1988?
Give a very brief answer. 0.95. What is the ratio of the Population growth (in %) of Kazakhstan in 1982 to that in 1988?
Provide a succinct answer. 0.2. What is the ratio of the Population growth (in %) in Nepal in 1982 to that in 1988?
Offer a very short reply. 1.09. What is the ratio of the Population growth (in %) of Least developed countries in 1983 to that in 1984?
Make the answer very short. 1.01. What is the ratio of the Population growth (in %) in Eritrea in 1983 to that in 1984?
Your answer should be compact. 0.98. What is the ratio of the Population growth (in %) in Kazakhstan in 1983 to that in 1984?
Make the answer very short. 0.9. What is the ratio of the Population growth (in %) in Nepal in 1983 to that in 1984?
Make the answer very short. 1.01. What is the ratio of the Population growth (in %) in Least developed countries in 1983 to that in 1985?
Make the answer very short. 1.01. What is the ratio of the Population growth (in %) in Eritrea in 1983 to that in 1985?
Provide a short and direct response. 0.93. What is the ratio of the Population growth (in %) in Kazakhstan in 1983 to that in 1985?
Provide a succinct answer. 0.2. What is the ratio of the Population growth (in %) in Nepal in 1983 to that in 1985?
Provide a succinct answer. 1.03. What is the ratio of the Population growth (in %) of Eritrea in 1983 to that in 1986?
Your response must be concise. 0.89. What is the ratio of the Population growth (in %) of Kazakhstan in 1983 to that in 1986?
Provide a short and direct response. 0.2. What is the ratio of the Population growth (in %) of Nepal in 1983 to that in 1986?
Provide a succinct answer. 1.07. What is the ratio of the Population growth (in %) in Eritrea in 1983 to that in 1987?
Your response must be concise. 0.88. What is the ratio of the Population growth (in %) of Kazakhstan in 1983 to that in 1987?
Your answer should be very brief. 0.19. What is the ratio of the Population growth (in %) of Nepal in 1983 to that in 1987?
Give a very brief answer. 1.09. What is the ratio of the Population growth (in %) in Least developed countries in 1983 to that in 1988?
Offer a very short reply. 0.99. What is the ratio of the Population growth (in %) of Eritrea in 1983 to that in 1988?
Ensure brevity in your answer.  0.96. What is the ratio of the Population growth (in %) of Kazakhstan in 1983 to that in 1988?
Your answer should be very brief. 0.23. What is the ratio of the Population growth (in %) of Nepal in 1983 to that in 1988?
Offer a very short reply. 1.08. What is the ratio of the Population growth (in %) of Least developed countries in 1984 to that in 1985?
Offer a terse response. 1. What is the ratio of the Population growth (in %) of Eritrea in 1984 to that in 1985?
Give a very brief answer. 0.95. What is the ratio of the Population growth (in %) in Kazakhstan in 1984 to that in 1985?
Your answer should be very brief. 0.23. What is the ratio of the Population growth (in %) of Nepal in 1984 to that in 1985?
Give a very brief answer. 1.02. What is the ratio of the Population growth (in %) of Least developed countries in 1984 to that in 1986?
Give a very brief answer. 0.99. What is the ratio of the Population growth (in %) of Eritrea in 1984 to that in 1986?
Provide a succinct answer. 0.91. What is the ratio of the Population growth (in %) of Kazakhstan in 1984 to that in 1986?
Provide a short and direct response. 0.22. What is the ratio of the Population growth (in %) of Nepal in 1984 to that in 1986?
Your answer should be compact. 1.05. What is the ratio of the Population growth (in %) in Eritrea in 1984 to that in 1987?
Keep it short and to the point. 0.9. What is the ratio of the Population growth (in %) of Kazakhstan in 1984 to that in 1987?
Provide a short and direct response. 0.22. What is the ratio of the Population growth (in %) in Nepal in 1984 to that in 1987?
Give a very brief answer. 1.08. What is the ratio of the Population growth (in %) in Least developed countries in 1984 to that in 1988?
Your answer should be very brief. 0.98. What is the ratio of the Population growth (in %) in Eritrea in 1984 to that in 1988?
Make the answer very short. 0.98. What is the ratio of the Population growth (in %) in Kazakhstan in 1984 to that in 1988?
Provide a succinct answer. 0.25. What is the ratio of the Population growth (in %) of Nepal in 1984 to that in 1988?
Give a very brief answer. 1.07. What is the ratio of the Population growth (in %) of Least developed countries in 1985 to that in 1986?
Keep it short and to the point. 0.99. What is the ratio of the Population growth (in %) of Eritrea in 1985 to that in 1986?
Your answer should be very brief. 0.96. What is the ratio of the Population growth (in %) in Kazakhstan in 1985 to that in 1986?
Offer a very short reply. 0.96. What is the ratio of the Population growth (in %) in Nepal in 1985 to that in 1986?
Keep it short and to the point. 1.03. What is the ratio of the Population growth (in %) of Least developed countries in 1985 to that in 1987?
Provide a short and direct response. 0.99. What is the ratio of the Population growth (in %) in Eritrea in 1985 to that in 1987?
Provide a succinct answer. 0.95. What is the ratio of the Population growth (in %) of Kazakhstan in 1985 to that in 1987?
Your answer should be compact. 0.96. What is the ratio of the Population growth (in %) in Nepal in 1985 to that in 1987?
Offer a very short reply. 1.06. What is the ratio of the Population growth (in %) in Least developed countries in 1985 to that in 1988?
Provide a succinct answer. 0.98. What is the ratio of the Population growth (in %) in Eritrea in 1985 to that in 1988?
Make the answer very short. 1.03. What is the ratio of the Population growth (in %) of Kazakhstan in 1985 to that in 1988?
Ensure brevity in your answer.  1.11. What is the ratio of the Population growth (in %) of Nepal in 1985 to that in 1988?
Offer a terse response. 1.05. What is the ratio of the Population growth (in %) in Eritrea in 1986 to that in 1987?
Offer a very short reply. 0.99. What is the ratio of the Population growth (in %) of Kazakhstan in 1986 to that in 1987?
Ensure brevity in your answer.  1. What is the ratio of the Population growth (in %) in Nepal in 1986 to that in 1987?
Make the answer very short. 1.02. What is the ratio of the Population growth (in %) of Least developed countries in 1986 to that in 1988?
Give a very brief answer. 0.99. What is the ratio of the Population growth (in %) in Eritrea in 1986 to that in 1988?
Offer a terse response. 1.07. What is the ratio of the Population growth (in %) of Kazakhstan in 1986 to that in 1988?
Offer a terse response. 1.16. What is the ratio of the Population growth (in %) in Nepal in 1986 to that in 1988?
Your answer should be compact. 1.02. What is the ratio of the Population growth (in %) of Eritrea in 1987 to that in 1988?
Your answer should be very brief. 1.09. What is the ratio of the Population growth (in %) of Kazakhstan in 1987 to that in 1988?
Ensure brevity in your answer.  1.16. What is the ratio of the Population growth (in %) in Nepal in 1987 to that in 1988?
Your answer should be compact. 0.99. What is the difference between the highest and the second highest Population growth (in %) in Least developed countries?
Give a very brief answer. 0. What is the difference between the highest and the second highest Population growth (in %) in Eritrea?
Offer a very short reply. 0.04. What is the difference between the highest and the second highest Population growth (in %) in Kazakhstan?
Offer a terse response. 0. What is the difference between the highest and the second highest Population growth (in %) of Nepal?
Your answer should be very brief. 0.01. What is the difference between the highest and the lowest Population growth (in %) in Least developed countries?
Provide a succinct answer. 0.04. What is the difference between the highest and the lowest Population growth (in %) of Eritrea?
Offer a terse response. 0.36. What is the difference between the highest and the lowest Population growth (in %) in Kazakhstan?
Provide a short and direct response. 0.85. What is the difference between the highest and the lowest Population growth (in %) of Nepal?
Your response must be concise. 0.18. 